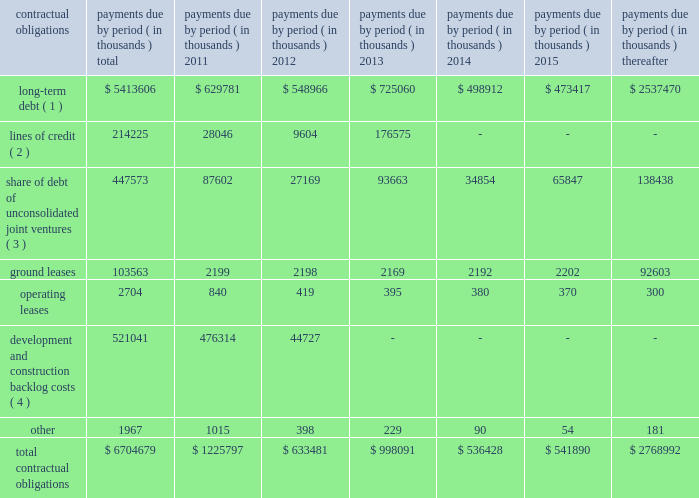39 annual report 2010 duke realty corporation | | related party transactions we provide property and asset management , leasing , construction and other tenant related services to unconsolidated companies in which we have equity interests .
For the years ended december 31 , 2010 , 2009 and 2008 , respectively , we earned management fees of $ 7.6 million , $ 8.4 million and $ 7.8 million , leasing fees of $ 2.7 million , $ 4.2 million and $ 2.8 million and construction and development fees of $ 10.3 million , $ 10.2 million and $ 12.7 million from these companies .
We recorded these fees based on contractual terms that approximate market rates for these types of services , and we have eliminated our ownership percentages of these fees in the consolidated financial statements .
Commitments and contingencies we have guaranteed the repayment of $ 95.4 million of economic development bonds issued by various municipalities in connection with certain commercial developments .
We will be required to make payments under our guarantees to the extent that incremental taxes from specified developments are not sufficient to pay the bond debt service .
Management does not believe that it is probable that we will be required to make any significant payments in satisfaction of these guarantees .
We also have guaranteed the repayment of secured and unsecured loans of six of our unconsolidated subsidiaries .
At december 31 , 2010 , the maximum guarantee exposure for these loans was approximately $ 245.4 million .
With the exception of the guarantee of the debt of 3630 peachtree joint venture , for which we recorded a contingent liability in 2009 of $ 36.3 million , management believes it probable that we will not be required to satisfy these guarantees .
We lease certain land positions with terms extending to december 2080 , with a total obligation of $ 103.6 million .
No payments on these ground leases are material in any individual year .
We are subject to various legal proceedings and claims that arise in the ordinary course of business .
In the opinion of management , the amount of any ultimate liability with respect to these actions will not materially affect our consolidated financial statements or results of operations .
Contractual obligations at december 31 , 2010 , we were subject to certain contractual payment obligations as described in the table below: .
( 1 ) our long-term debt consists of both secured and unsecured debt and includes both principal and interest .
Interest expense for variable rate debt was calculated using the interest rates as of december 31 , 2010 .
( 2 ) our unsecured lines of credit consist of an operating line of credit that matures february 2013 and the line of credit of a consolidated subsidiary that matures july 2011 .
Interest expense for our unsecured lines of credit was calculated using the most recent stated interest rates that were in effect .
( 3 ) our share of unconsolidated joint venture debt includes both principal and interest .
Interest expense for variable rate debt was calculated using the interest rate at december 31 , 2010 .
( 4 ) represents estimated remaining costs on the completion of owned development projects and third-party construction projects. .
What was the percent of the total contractual obligations associated with lines of credit that was due in 2011? 
Computations: (28046 / 1225797)
Answer: 0.02288. 